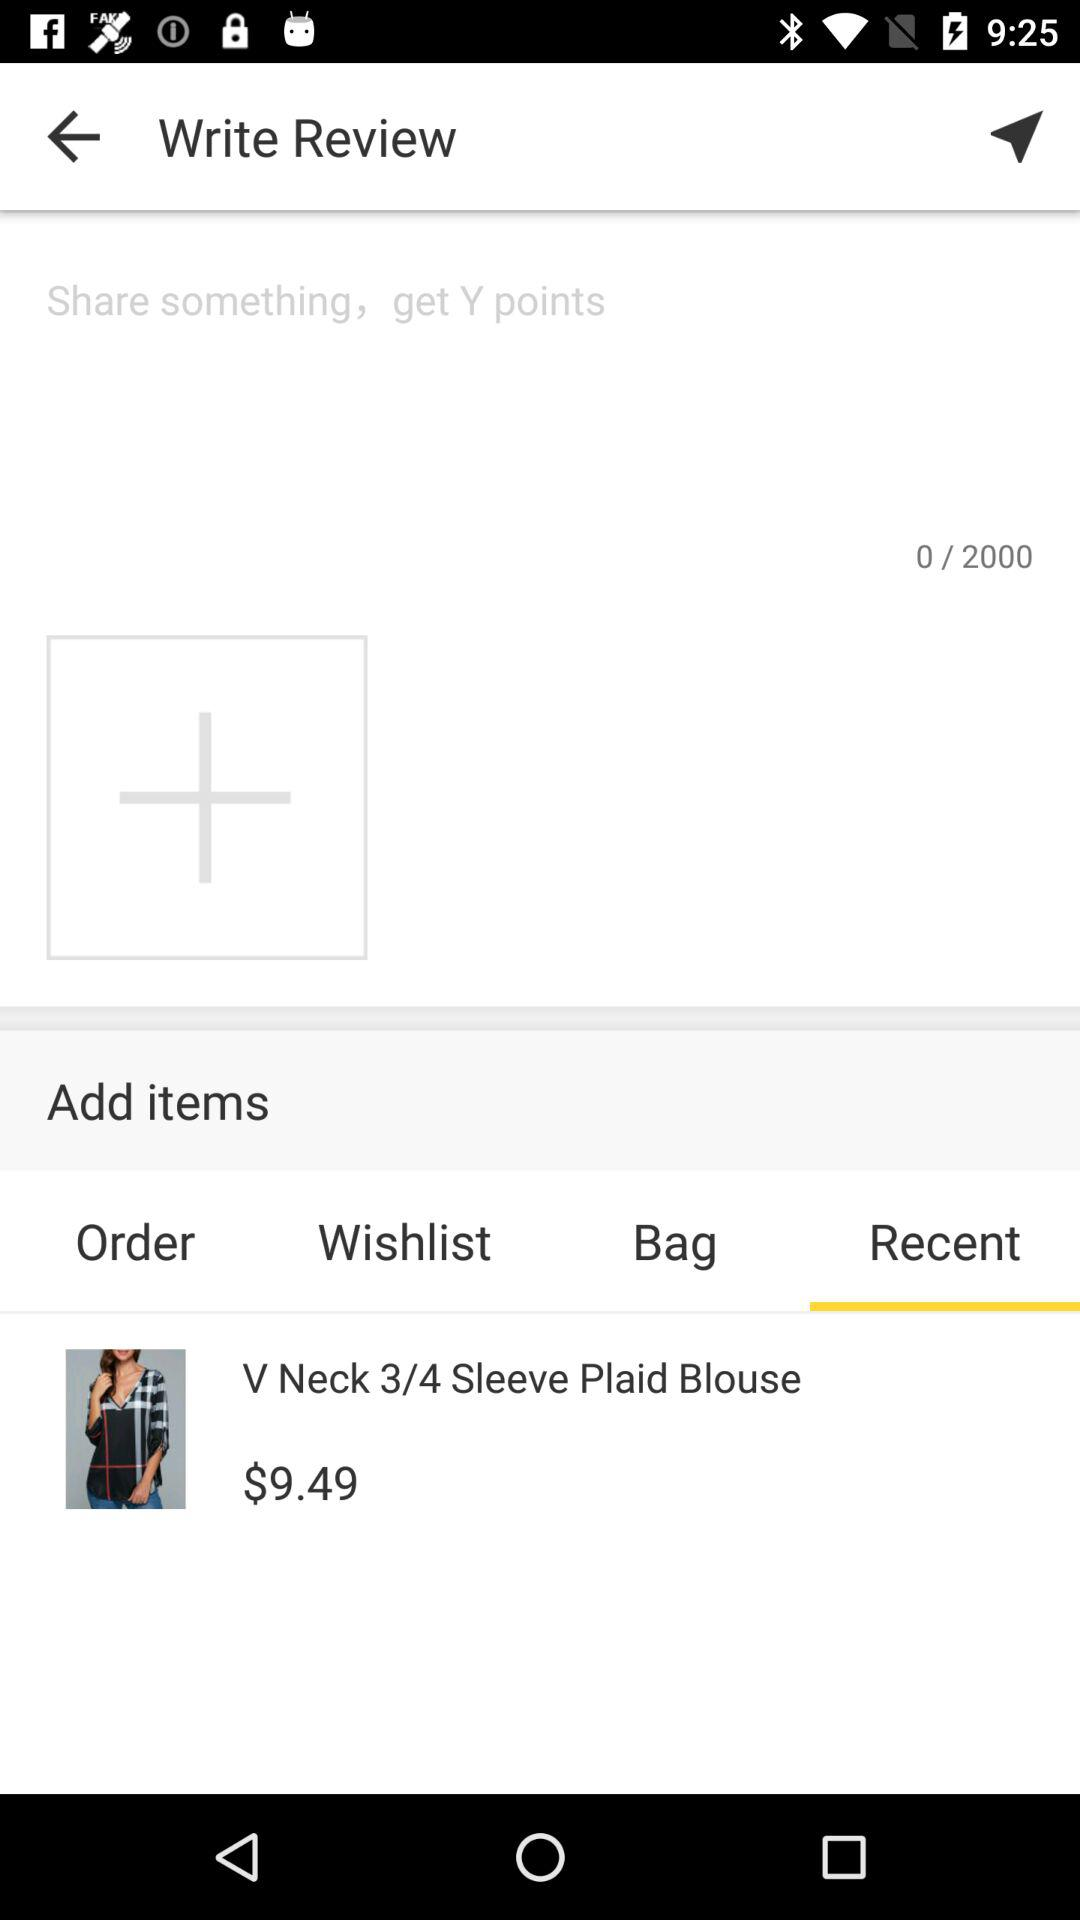How much is the product priced at?
Answer the question using a single word or phrase. $9.49 